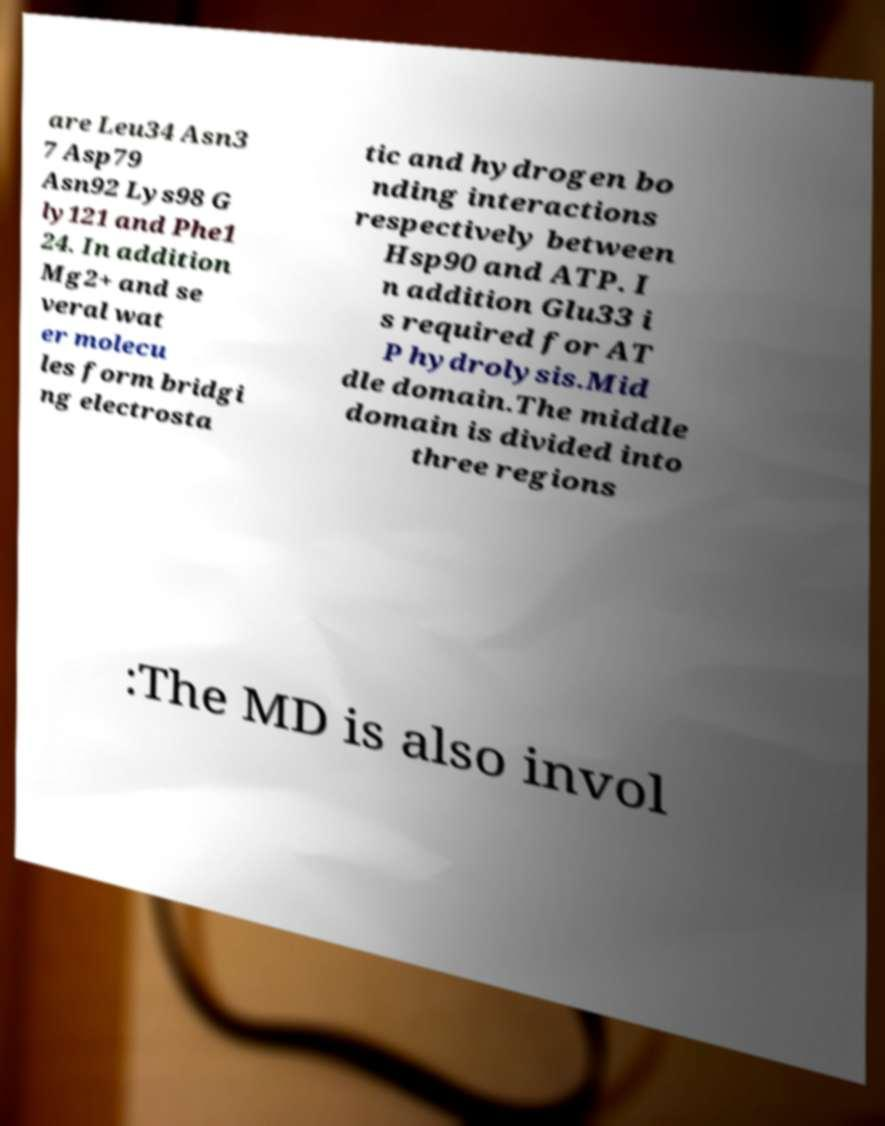Please identify and transcribe the text found in this image. are Leu34 Asn3 7 Asp79 Asn92 Lys98 G ly121 and Phe1 24. In addition Mg2+ and se veral wat er molecu les form bridgi ng electrosta tic and hydrogen bo nding interactions respectively between Hsp90 and ATP. I n addition Glu33 i s required for AT P hydrolysis.Mid dle domain.The middle domain is divided into three regions :The MD is also invol 